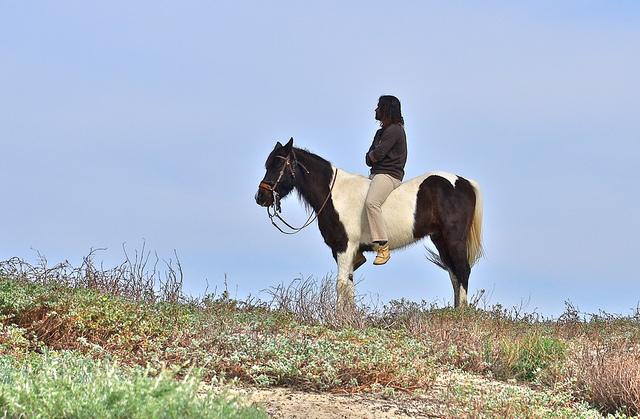What is the color of the horse?
Keep it brief. Brown and white. Is this person alone?
Keep it brief. Yes. How many animals are in the picture?
Quick response, please. 1. 